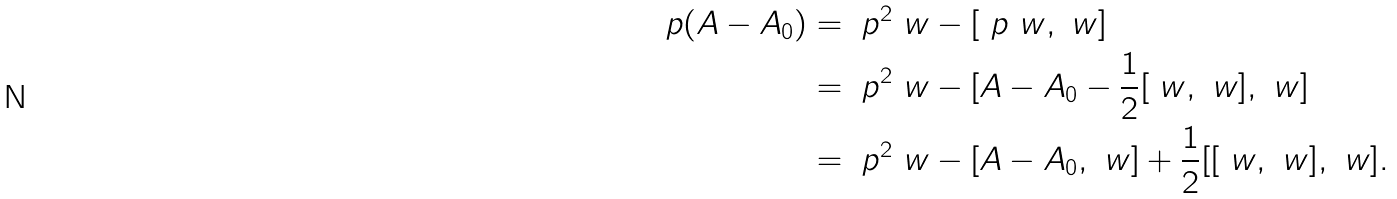<formula> <loc_0><loc_0><loc_500><loc_500>\ p ( A - A _ { 0 } ) & = \ p ^ { 2 } \ w - [ \ p \ w , \ w ] \\ & = \ p ^ { 2 } \ w - [ A - A _ { 0 } - \frac { 1 } { 2 } [ \ w , \ w ] , \ w ] \\ & = \ p ^ { 2 } \ w - [ A - A _ { 0 } , \ w ] + \frac { 1 } { 2 } [ [ \ w , \ w ] , \ w ] .</formula> 